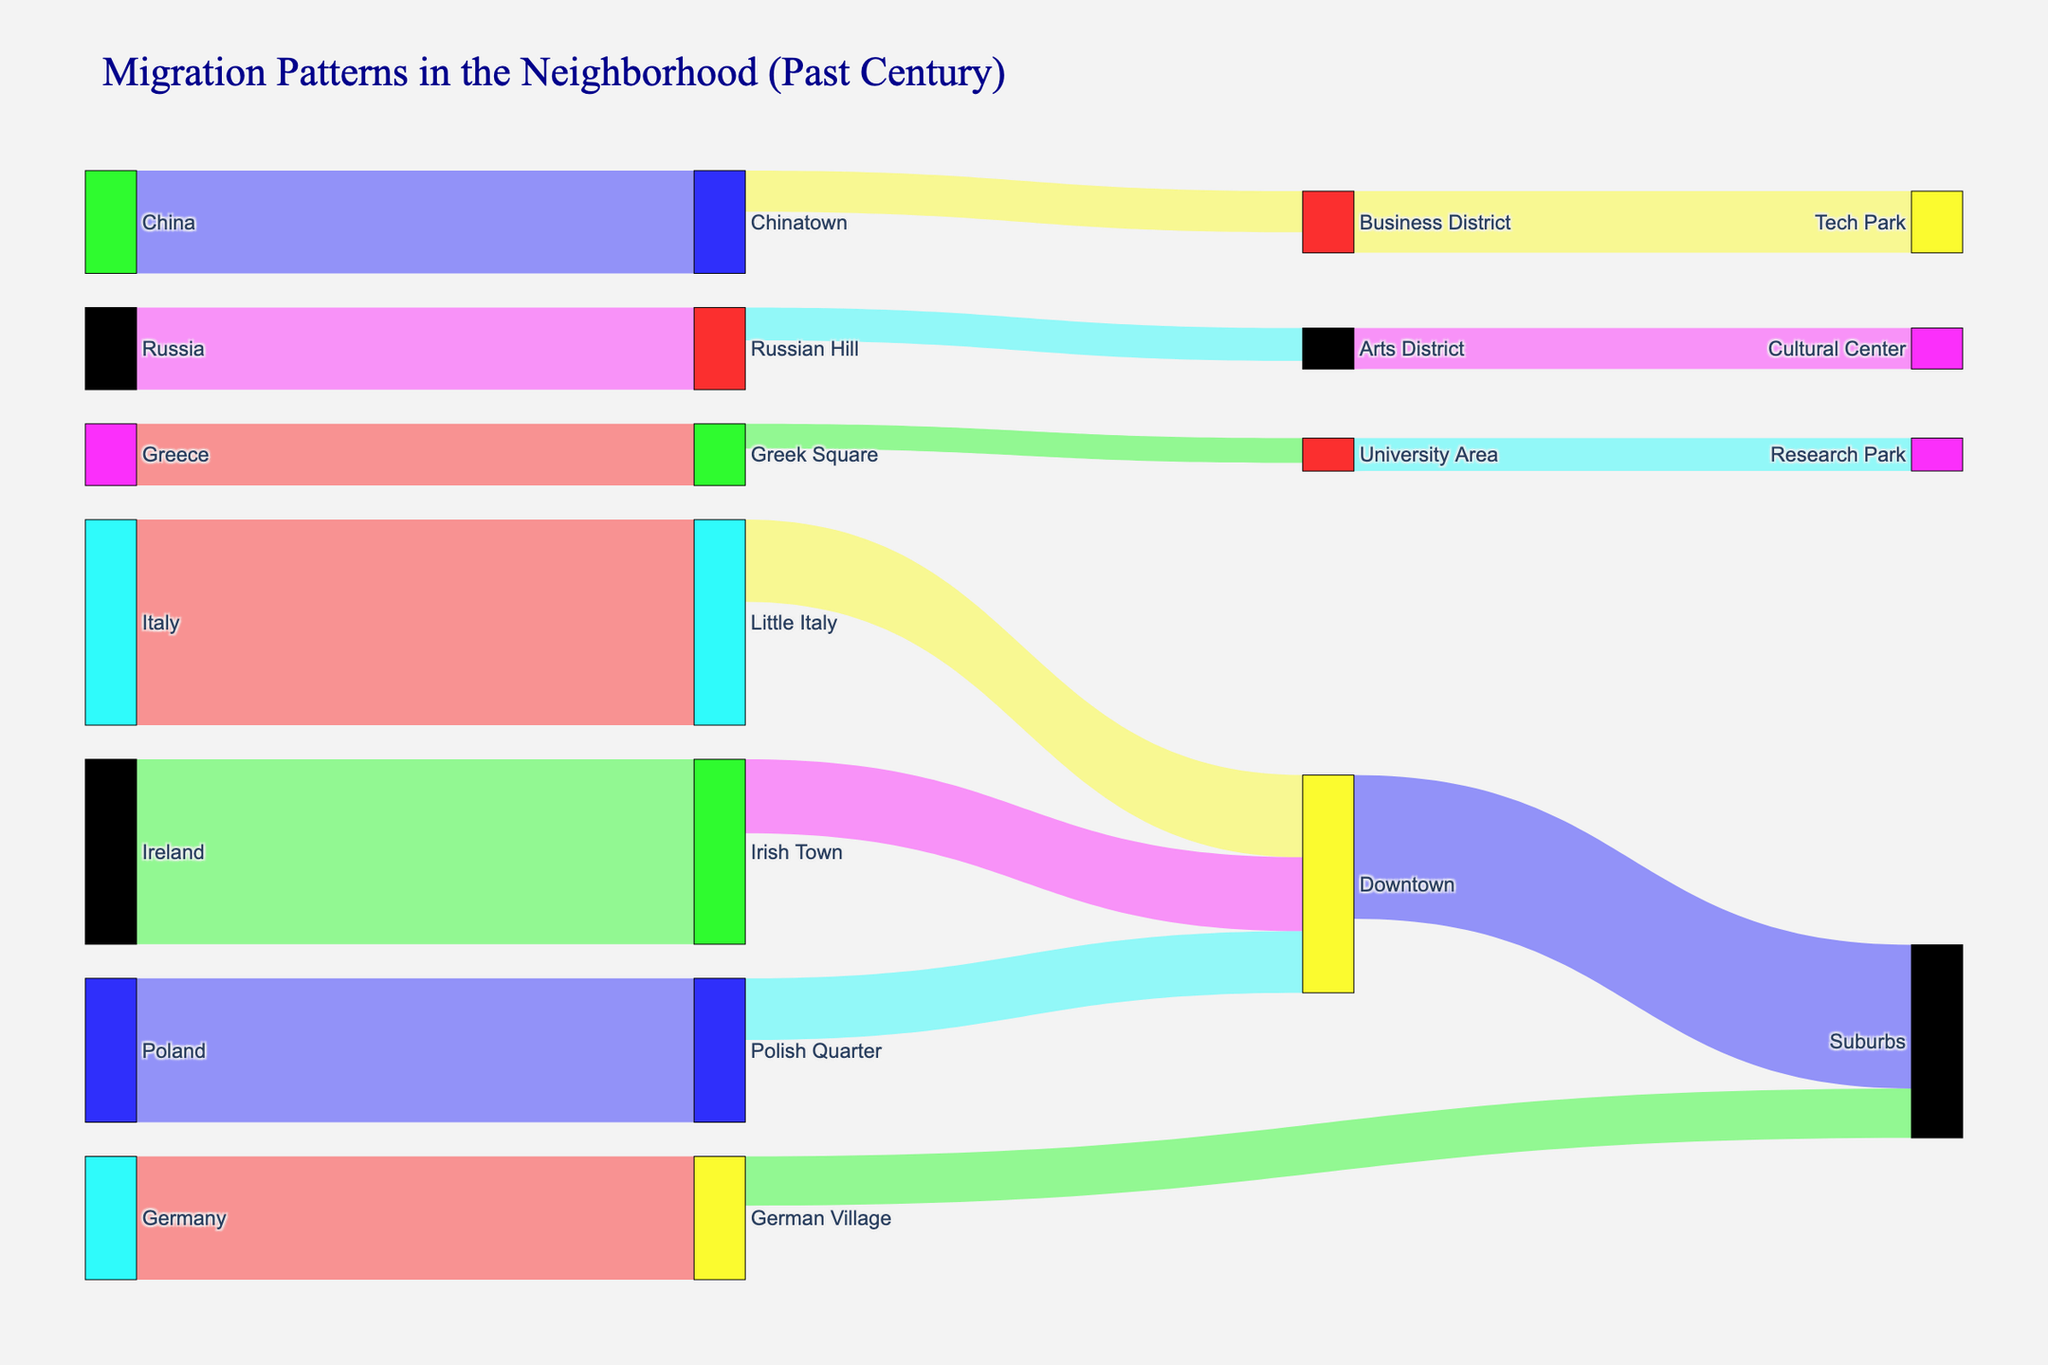What is the title of the figure? The title is clearly stated at the top of the figure in a larger font size. It reflects the theme of the Sankey diagram, describing the overall purpose of the visual.
Answer: Migration Patterns in the Neighborhood (Past Century) Which group had the highest initial migration value? By examining the thickness of the flows and the labels, it is clear that the group migrating from Italy to Little Italy has the thickest flow, representing the highest value.
Answer: Italy to Little Italy How many different ethnic groups are represented in the diagram? Count the distinct sources from the data, which include Italy, Ireland, Poland, Germany, China, Russia, and Greece.
Answer: 7 Which neighborhood received the smallest migration flow from an ethnic group, and what was the value? Look for the thinnest flow lines representing the smallest values. The flow from Greek Square to the University Area is the smallest at 600.
Answer: Greek Square to University Area, 600 What is the combined value of migration from Downtown to Suburbs and Business District to Tech Park? Add the values for the flows from Downtown to Suburbs and Business District to Tech Park, which are 3500 and 1500, respectively.
Answer: 3500 + 1500 = 5000 From which ethnic group does the German Village receive its population? Trace the flow paths leading into German Village, which shows the migration from Germany.
Answer: Germany How does the migration from Little Italy to Downtown compare to that from Irish Town to Downtown in value? Compare the values; Little Italy to Downtown is 2000, and Irish Town to Downtown is 1800.
Answer: Little Italy to Downtown is greater Which areas receive migrations directly from ethnic-specific neighborhoods (not intermediate hubs)? Identify target neighborhoods that receive direct flows from ethnic neighborhoods: Little Italy, Irish Town, Polish Quarter, German Village, Chinatown, Russian Hill, Greek Square.
Answer: 7 specific neighborhoods What is the total migration flow reaching Downtown from specific ethnic neighborhoods combined (Little Italy, Irish Town, Polish Quarter)? Sum the values for flows into Downtown from Little Italy, Irish Town, and Polish Quarter, which are 2000, 1800, and 1500, respectively.
Answer: 2000 + 1800 + 1500 = 5300 Which two neighborhoods have the most interconnected flows? Identify neighborhoods that exchange the most flows back and forth; Downtown and Suburbs both have high inflows and outflows.
Answer: Downtown and Suburbs 